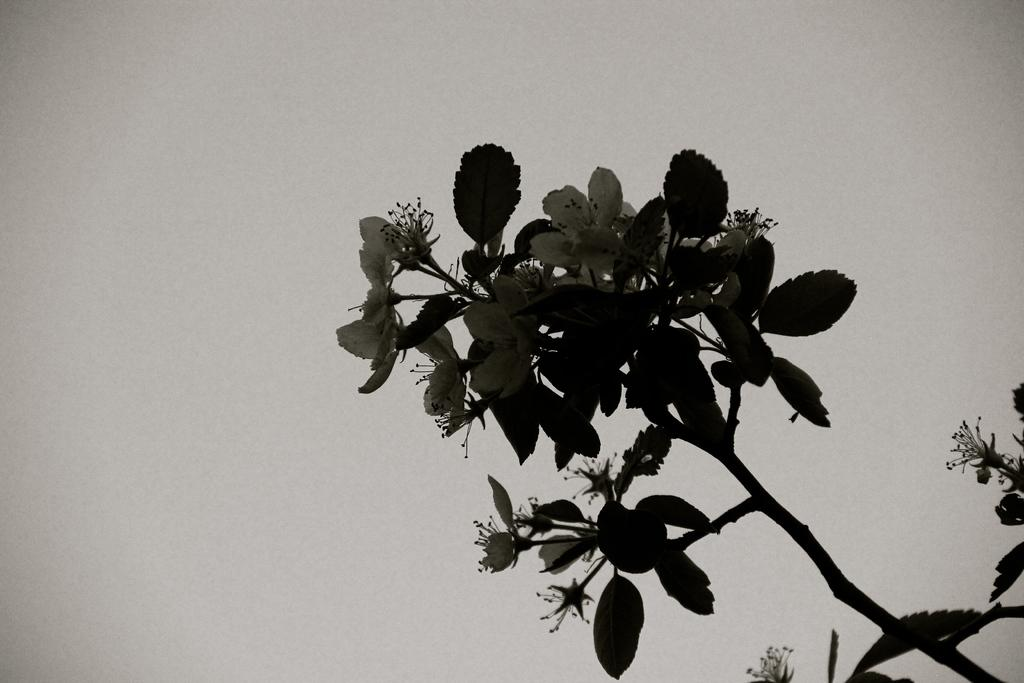What type of plant life is present in the image? There are flowers, leaves, and a stem of a plant in the image. Can you describe the plant's structure? The plant has a stem, leaves, and flowers. What is visible in the background of the image? The sky is visible in the background of the image. What type of division is taking place in the image? There is no division taking place in the image; it features a plant with flowers, leaves, and a stem. What type of fall is depicted in the image? There is no fall depicted in the image; it features a plant with flowers, leaves, and a stem. 